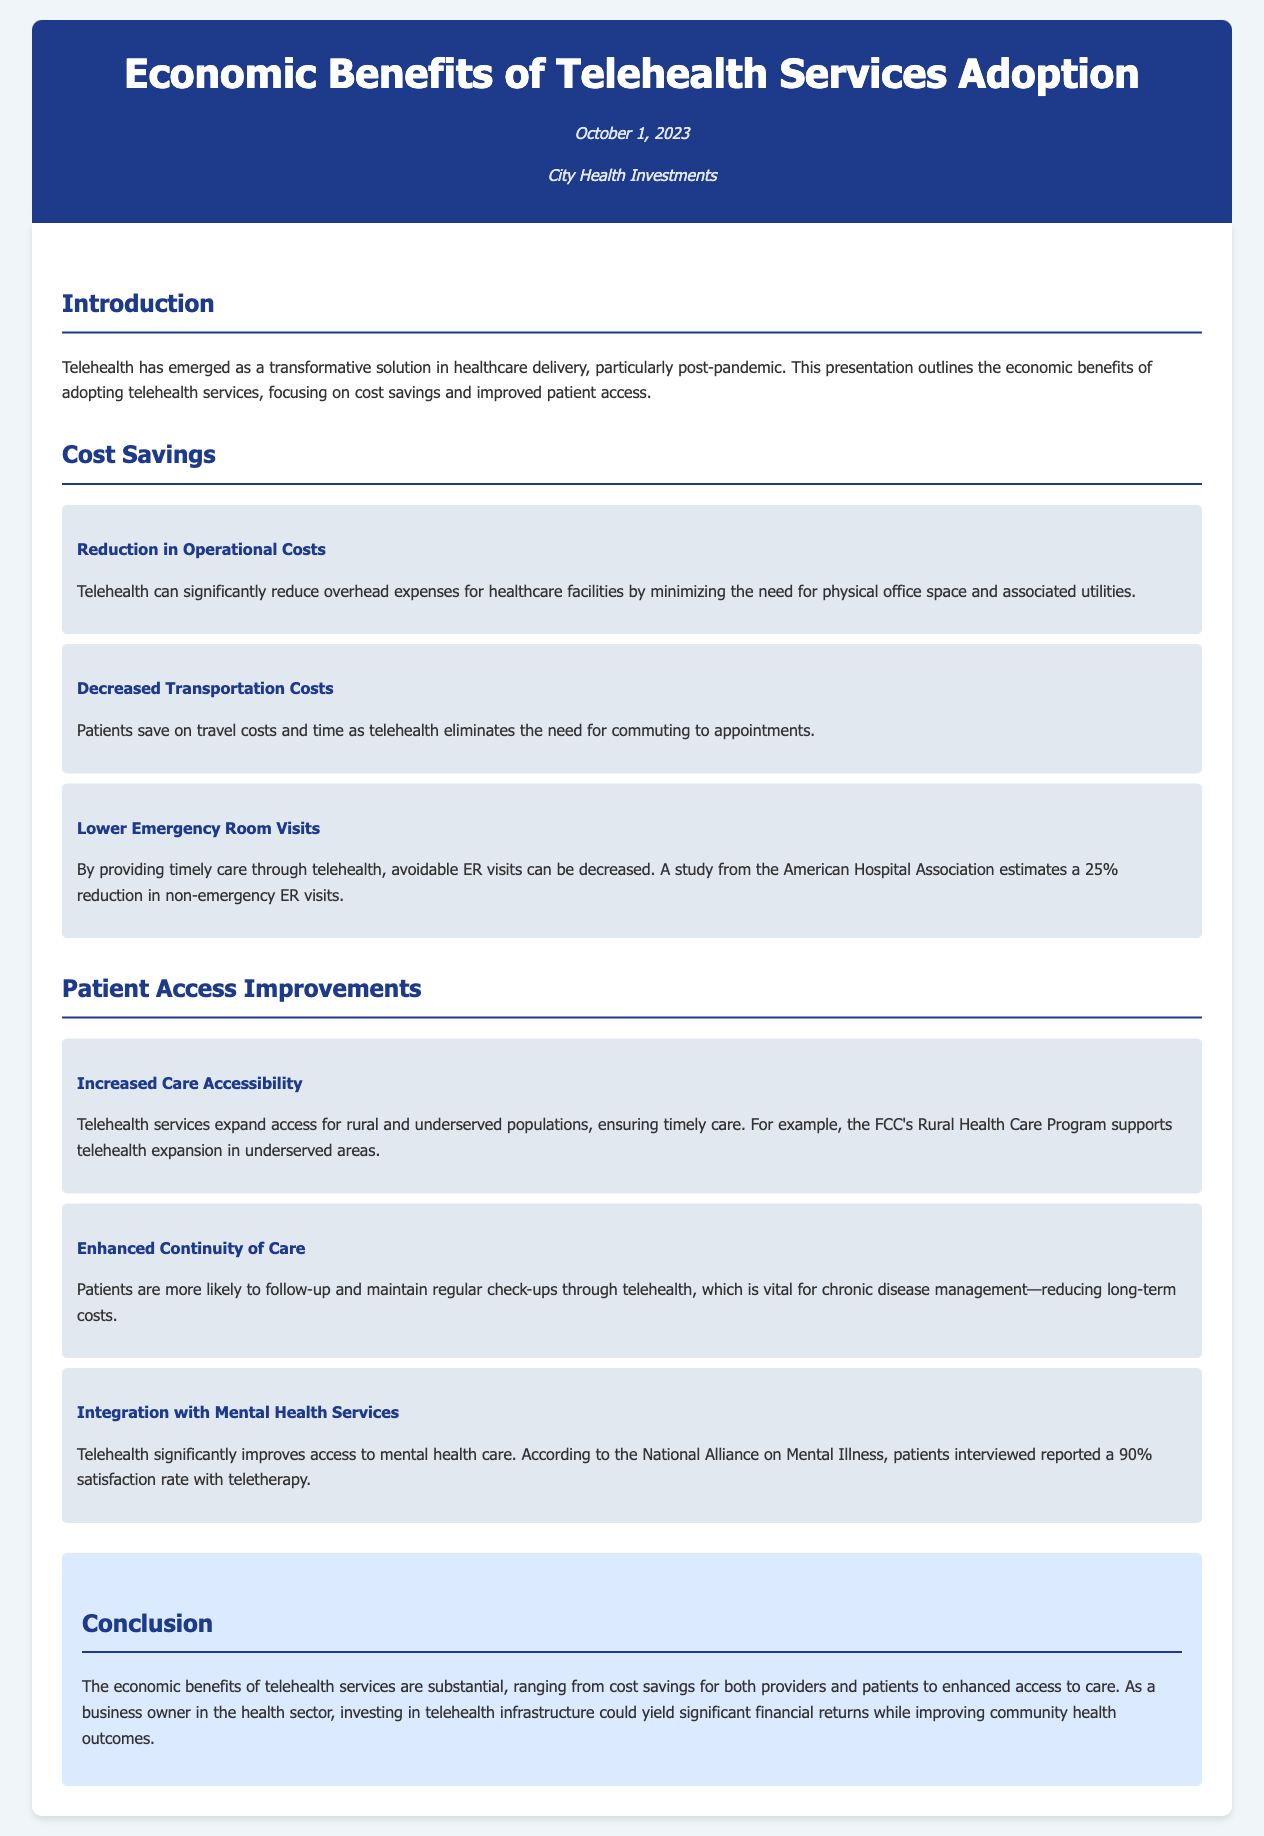What is the date of the presentation? The date of the presentation is mentioned at the top of the document.
Answer: October 1, 2023 Who is the owner of the document? The owner of the document is indicated in the header section.
Answer: City Health Investments What is a major benefit of telehealth mentioned in the cost savings section? The document lists various cost-saving benefits under the cost savings section.
Answer: Reduction in Operational Costs By what percentage can non-emergency ER visits be reduced according to the document? The document provides a specific estimate from the American Hospital Association for ER visit reductions.
Answer: 25% What type of populations benefit from increased care accessibility? The document specifies the types of populations that benefit from telehealth addressing accessibility.
Answer: Rural and underserved populations What is the reported satisfaction rate for teletherapy according to the document? The document cites a specific percentage regarding patient satisfaction with teletherapy.
Answer: 90% What aspect of care does telehealth enhance according to the document? The document discusses continuity in terms of care management offered through telehealth services.
Answer: Enhanced Continuity of Care What conclusion is drawn about the economic benefits of telehealth services? The document provides a summary statement regarding the overall economic impact of telehealth.
Answer: Substantial economic benefits What program supports telehealth expansion in underserved areas? The document references a specific program that aids in the telehealth expansion effort.
Answer: FCC's Rural Health Care Program 